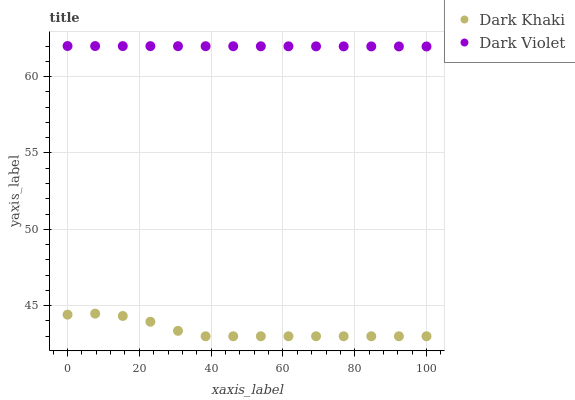Does Dark Khaki have the minimum area under the curve?
Answer yes or no. Yes. Does Dark Violet have the maximum area under the curve?
Answer yes or no. Yes. Does Dark Violet have the minimum area under the curve?
Answer yes or no. No. Is Dark Violet the smoothest?
Answer yes or no. Yes. Is Dark Khaki the roughest?
Answer yes or no. Yes. Is Dark Violet the roughest?
Answer yes or no. No. Does Dark Khaki have the lowest value?
Answer yes or no. Yes. Does Dark Violet have the lowest value?
Answer yes or no. No. Does Dark Violet have the highest value?
Answer yes or no. Yes. Is Dark Khaki less than Dark Violet?
Answer yes or no. Yes. Is Dark Violet greater than Dark Khaki?
Answer yes or no. Yes. Does Dark Khaki intersect Dark Violet?
Answer yes or no. No. 